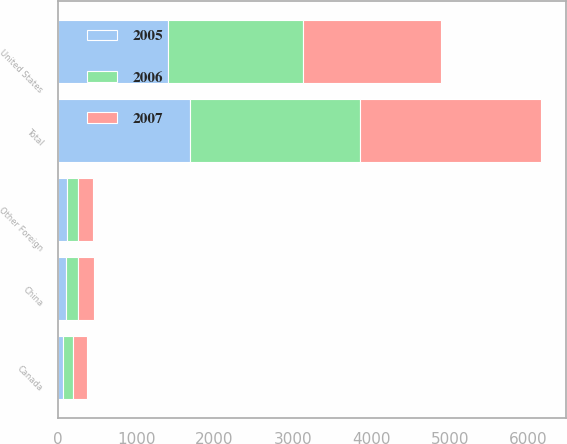Convert chart. <chart><loc_0><loc_0><loc_500><loc_500><stacked_bar_chart><ecel><fcel>United States<fcel>China<fcel>Canada<fcel>Other Foreign<fcel>Total<nl><fcel>2007<fcel>1757<fcel>197.6<fcel>171.9<fcel>185.6<fcel>2312.1<nl><fcel>2006<fcel>1720.9<fcel>154.2<fcel>137.3<fcel>148.9<fcel>2161.3<nl><fcel>2005<fcel>1400.6<fcel>106.8<fcel>64.5<fcel>117.3<fcel>1689.2<nl></chart> 